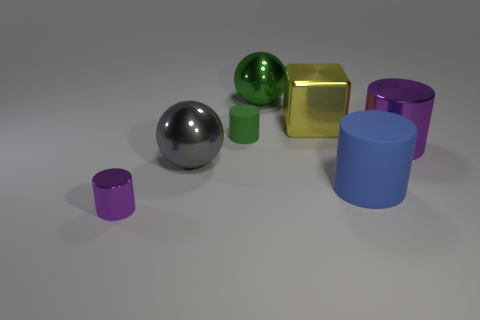Subtract all green blocks. How many purple cylinders are left? 2 Subtract all tiny purple metal cylinders. How many cylinders are left? 3 Subtract all blue cylinders. How many cylinders are left? 3 Add 1 tiny purple shiny things. How many objects exist? 8 Subtract all brown cylinders. Subtract all brown blocks. How many cylinders are left? 4 Add 2 rubber things. How many rubber things are left? 4 Add 6 large brown metal cylinders. How many large brown metal cylinders exist? 6 Subtract 0 cyan balls. How many objects are left? 7 Subtract all cylinders. How many objects are left? 3 Subtract all gray shiny balls. Subtract all yellow things. How many objects are left? 5 